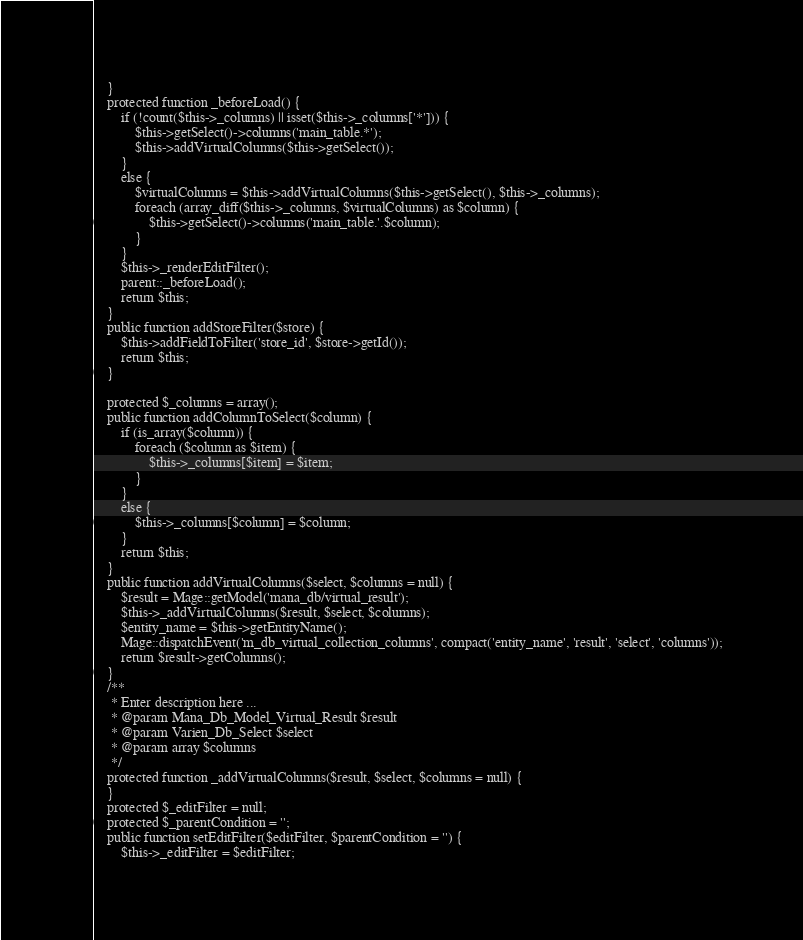<code> <loc_0><loc_0><loc_500><loc_500><_PHP_>	}
	protected function _beforeLoad() {
		if (!count($this->_columns) || isset($this->_columns['*'])) {
			$this->getSelect()->columns('main_table.*');
			$this->addVirtualColumns($this->getSelect());
		}
		else {
			$virtualColumns = $this->addVirtualColumns($this->getSelect(), $this->_columns);
			foreach (array_diff($this->_columns, $virtualColumns) as $column) {
				$this->getSelect()->columns('main_table.'.$column);
			}
		}
		$this->_renderEditFilter();
		parent::_beforeLoad();
		return $this;
	}
	public function addStoreFilter($store) {
        $this->addFieldToFilter('store_id', $store->getId());
        return $this;
    }
    
	protected $_columns = array();
	public function addColumnToSelect($column) {
		if (is_array($column)) {
			foreach ($column as $item) {
				$this->_columns[$item] = $item;
			}
		}
		else {
			$this->_columns[$column] = $column;
		}
		return $this;
	}
	public function addVirtualColumns($select, $columns = null) {
		$result = Mage::getModel('mana_db/virtual_result');
		$this->_addVirtualColumns($result, $select, $columns);
		$entity_name = $this->getEntityName();
		Mage::dispatchEvent('m_db_virtual_collection_columns', compact('entity_name', 'result', 'select', 'columns'));
		return $result->getColumns();
	}
	/**
	 * Enter description here ...
	 * @param Mana_Db_Model_Virtual_Result $result
	 * @param Varien_Db_Select $select
	 * @param array $columns
	 */
	protected function _addVirtualColumns($result, $select, $columns = null) {
	}
    protected $_editFilter = null;
    protected $_parentCondition = '';
    public function setEditFilter($editFilter, $parentCondition = '') {
        $this->_editFilter = $editFilter;</code> 